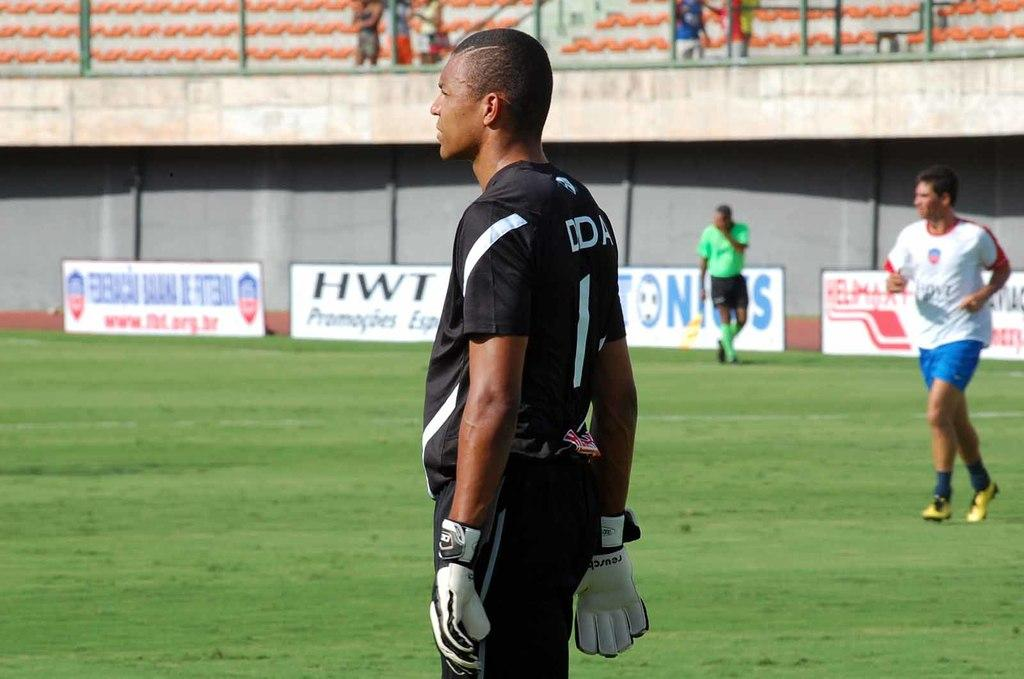<image>
Write a terse but informative summary of the picture. Athletes on a field that is sponsored by a company called HWT. 